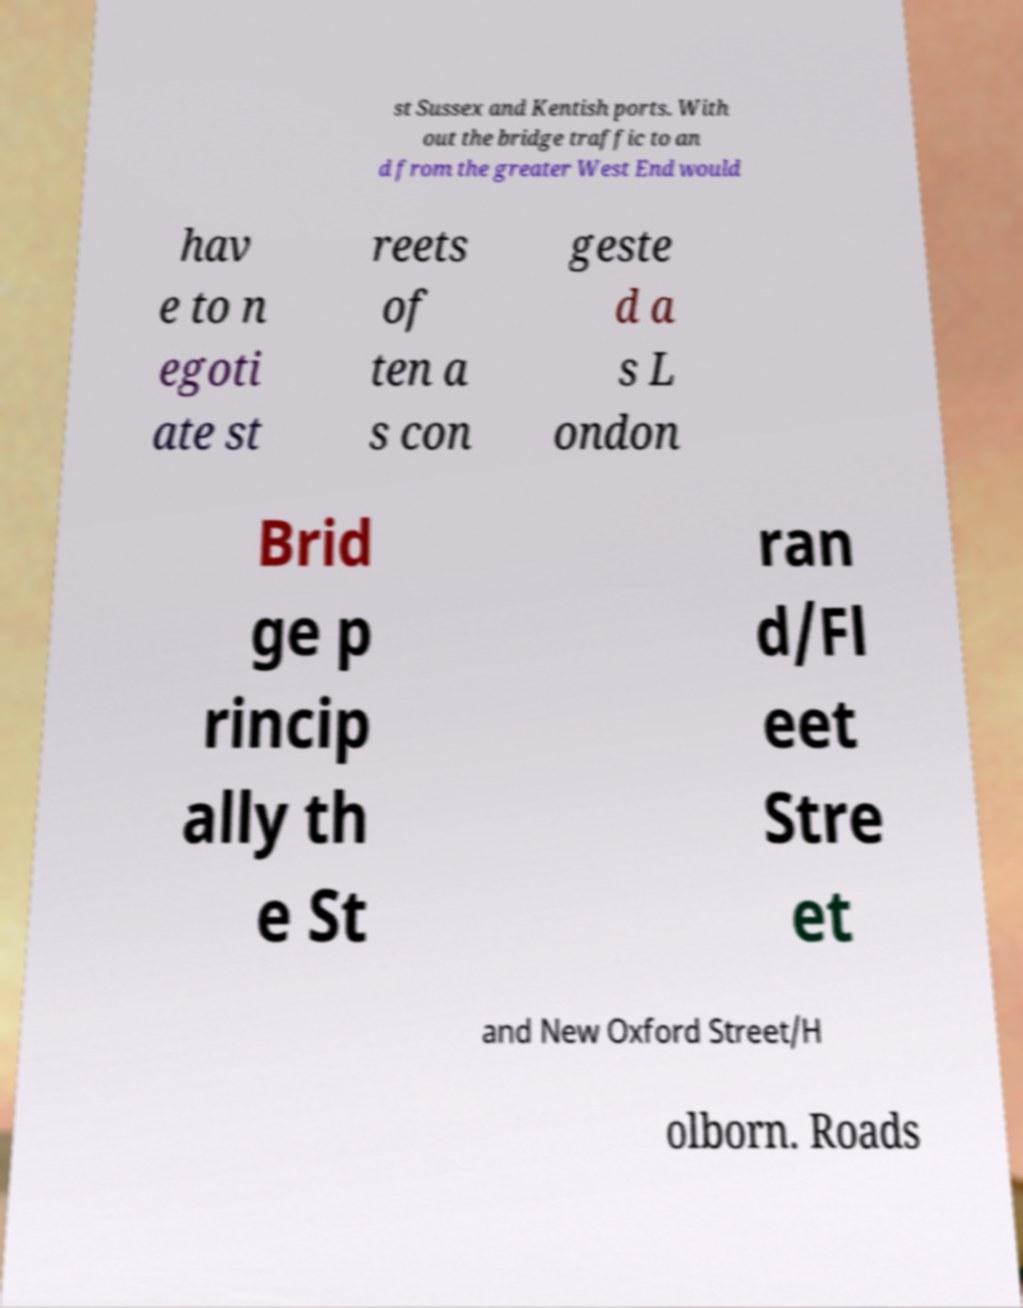Could you assist in decoding the text presented in this image and type it out clearly? st Sussex and Kentish ports. With out the bridge traffic to an d from the greater West End would hav e to n egoti ate st reets of ten a s con geste d a s L ondon Brid ge p rincip ally th e St ran d/Fl eet Stre et and New Oxford Street/H olborn. Roads 